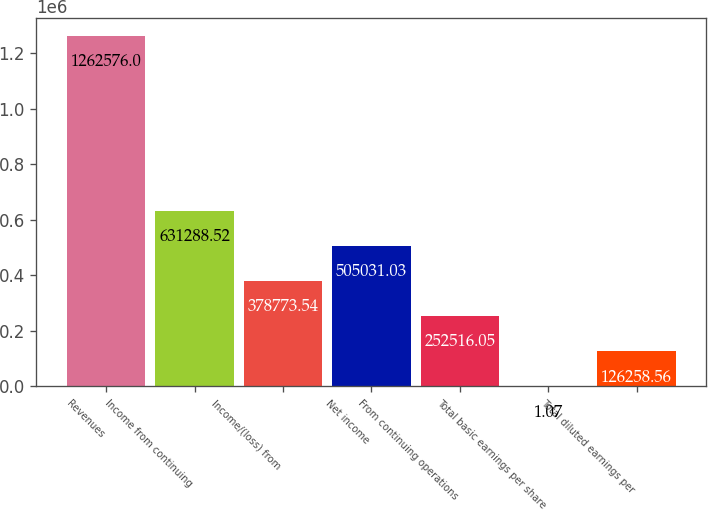Convert chart to OTSL. <chart><loc_0><loc_0><loc_500><loc_500><bar_chart><fcel>Revenues<fcel>Income from continuing<fcel>Income/(loss) from<fcel>Net income<fcel>From continuing operations<fcel>Total basic earnings per share<fcel>Total diluted earnings per<nl><fcel>1.26258e+06<fcel>631289<fcel>378774<fcel>505031<fcel>252516<fcel>1.07<fcel>126259<nl></chart> 